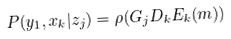<formula> <loc_0><loc_0><loc_500><loc_500>P ( y _ { 1 } , x _ { k } | z _ { j } ) = \rho ( G _ { j } D _ { k } E _ { k } ( m ) )</formula> 